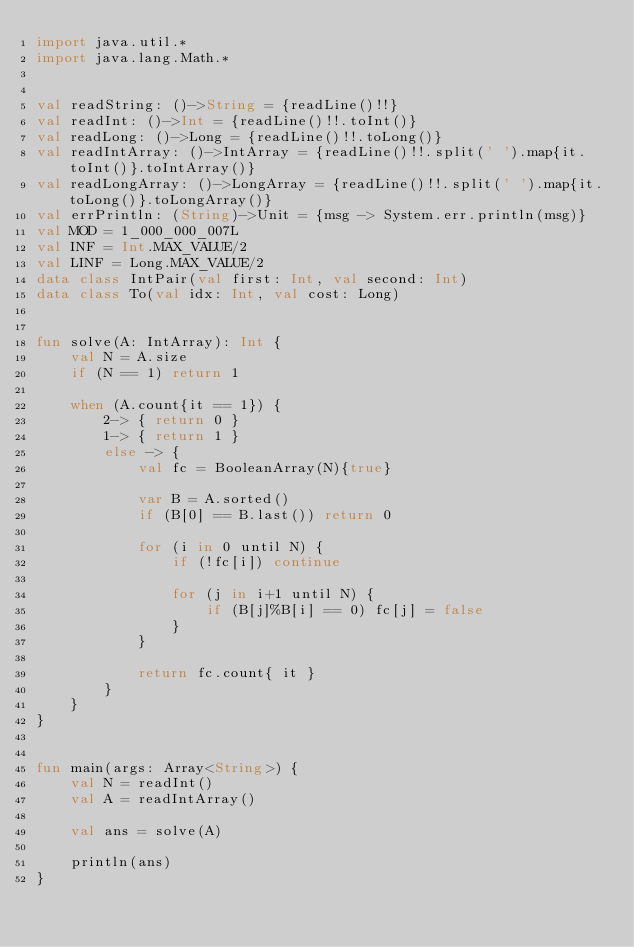<code> <loc_0><loc_0><loc_500><loc_500><_Kotlin_>import java.util.*
import java.lang.Math.*


val readString: ()->String = {readLine()!!}
val readInt: ()->Int = {readLine()!!.toInt()}
val readLong: ()->Long = {readLine()!!.toLong()}
val readIntArray: ()->IntArray = {readLine()!!.split(' ').map{it.toInt()}.toIntArray()}
val readLongArray: ()->LongArray = {readLine()!!.split(' ').map{it.toLong()}.toLongArray()}
val errPrintln: (String)->Unit = {msg -> System.err.println(msg)}
val MOD = 1_000_000_007L
val INF = Int.MAX_VALUE/2
val LINF = Long.MAX_VALUE/2
data class IntPair(val first: Int, val second: Int)
data class To(val idx: Int, val cost: Long)


fun solve(A: IntArray): Int {
    val N = A.size
    if (N == 1) return 1

    when (A.count{it == 1}) {
        2-> { return 0 }
        1-> { return 1 }
        else -> {
            val fc = BooleanArray(N){true}

            var B = A.sorted()
            if (B[0] == B.last()) return 0

            for (i in 0 until N) {
                if (!fc[i]) continue

                for (j in i+1 until N) {
                    if (B[j]%B[i] == 0) fc[j] = false
                }
            }

            return fc.count{ it }
        }
    }
}


fun main(args: Array<String>) {
    val N = readInt()
    val A = readIntArray()

    val ans = solve(A)

    println(ans)
}
</code> 